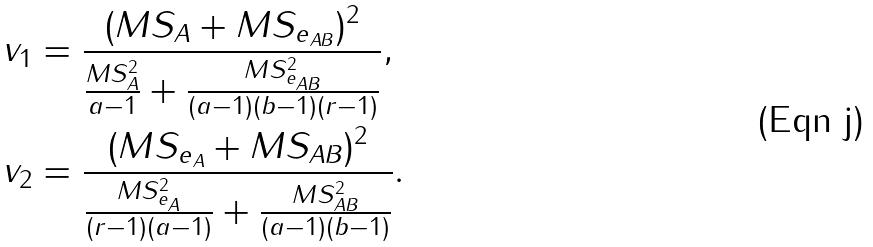<formula> <loc_0><loc_0><loc_500><loc_500>v _ { 1 } & = \frac { ( M S _ { A } + M S _ { e _ { A B } } ) ^ { 2 } } { \frac { M S _ { A } ^ { 2 } } { a - 1 } + \frac { M S _ { e _ { A B } } ^ { 2 } } { ( a - 1 ) ( b - 1 ) ( r - 1 ) } } , \\ v _ { 2 } & = \frac { ( M S _ { e _ { A } } + M S _ { A B } ) ^ { 2 } } { \frac { M S _ { e _ { A } } ^ { 2 } } { ( r - 1 ) ( a - 1 ) } + \frac { M S _ { A B } ^ { 2 } } { ( a - 1 ) ( b - 1 ) } } .</formula> 